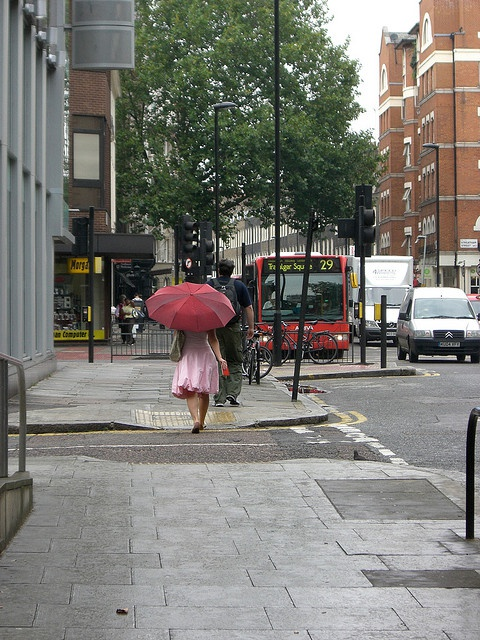Describe the objects in this image and their specific colors. I can see bus in gray, black, and brown tones, car in gray, black, white, and lightblue tones, truck in gray, white, darkgray, and black tones, people in gray, maroon, and darkgray tones, and umbrella in gray, brown, and salmon tones in this image. 